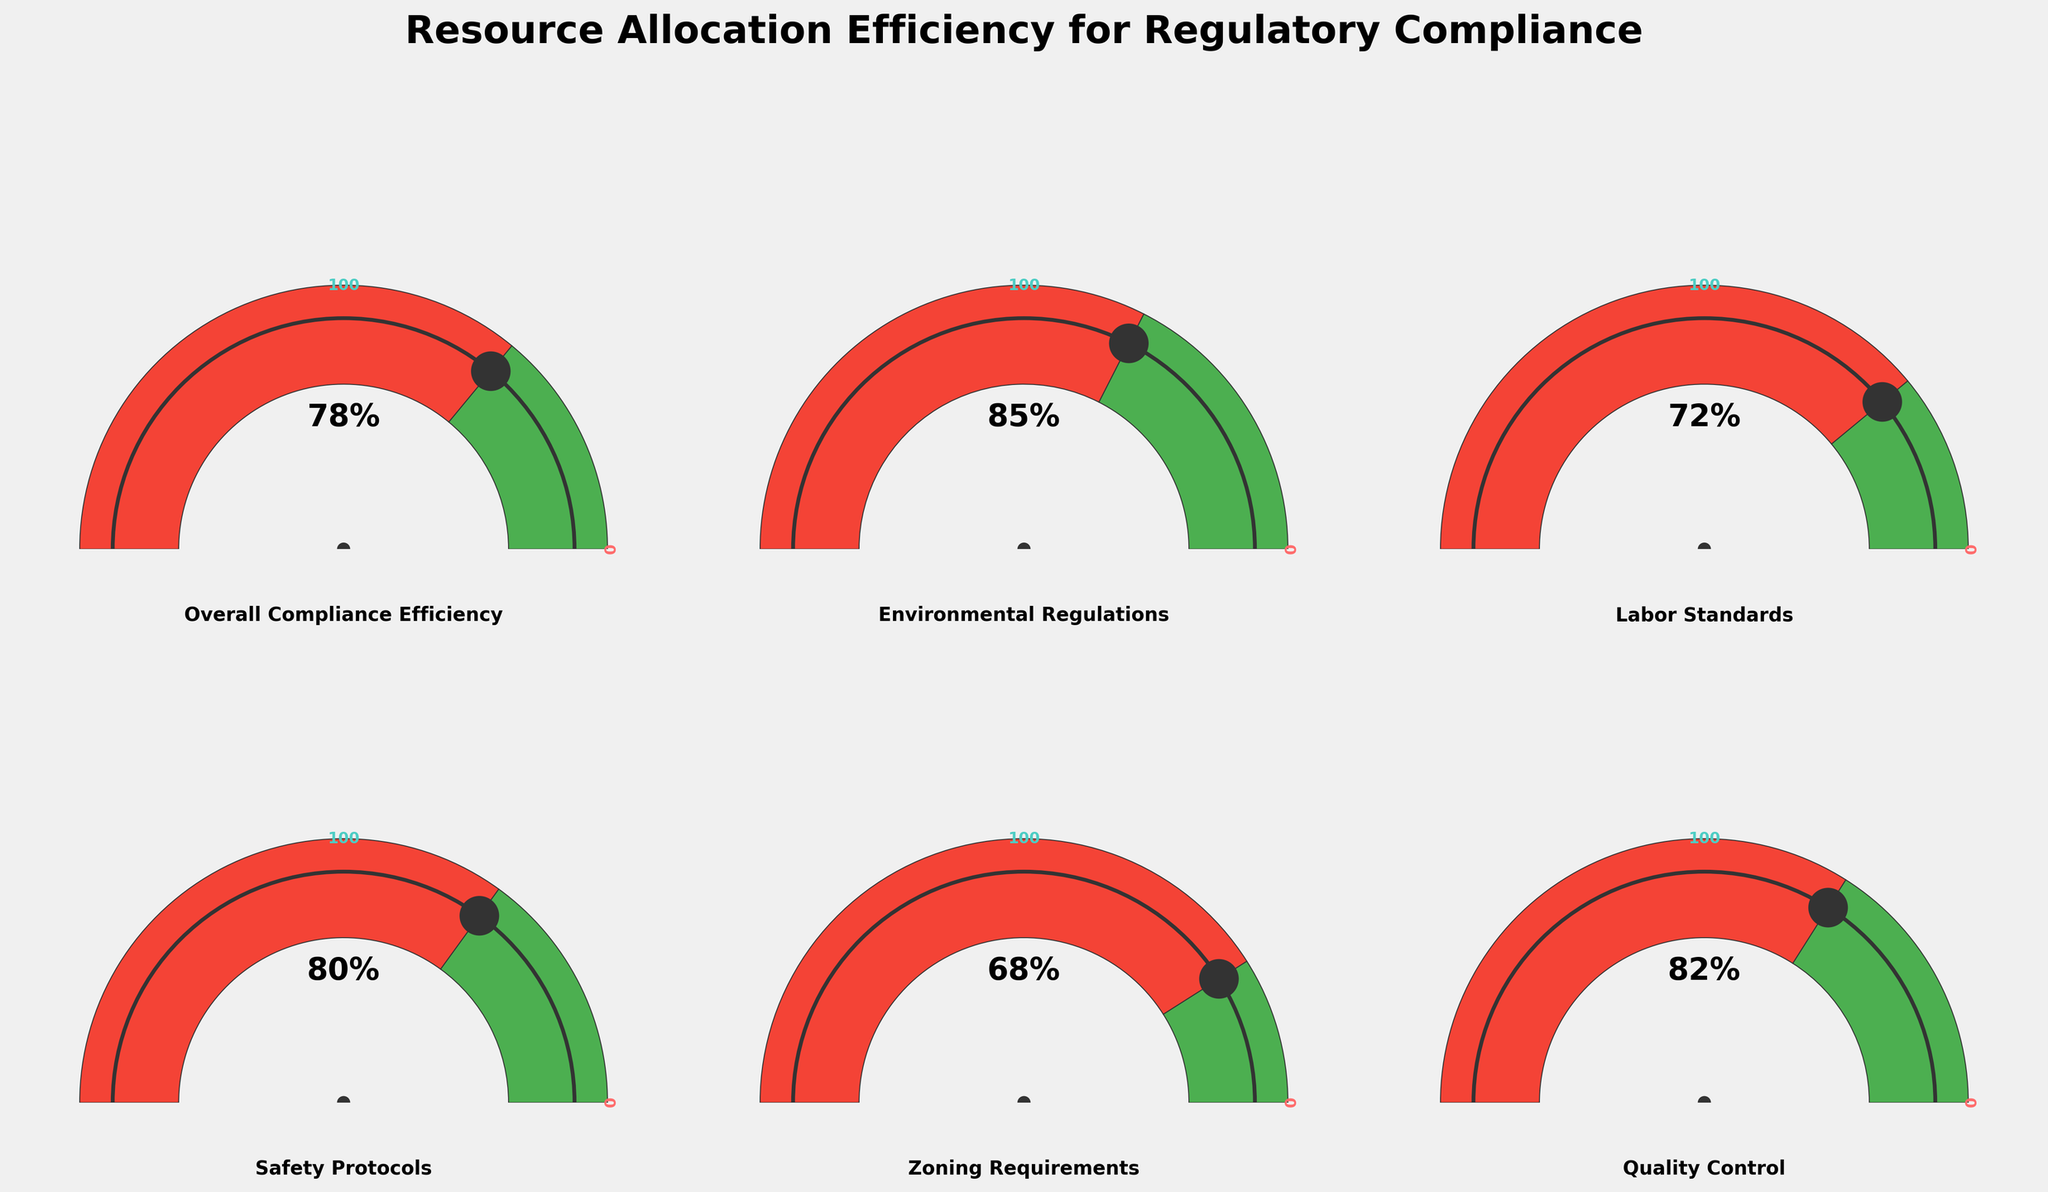What is the overall compliance efficiency? Look at the gauge chart labeled "Overall Compliance Efficiency" and read the percentage value indicated by the needle.
Answer: 78% Which category has the highest efficiency value? Examine all the gauge charts and identify the one with the highest percentage value.
Answer: Environmental Regulations Which category has the lowest efficiency value? Examine all the gauge charts and identify the one with the lowest percentage value.
Answer: Zoning Requirements How many categories have an efficiency value greater than 80%? Inspect each gauge chart, count the categories with values greater than 80%. There are "Overall Compliance Efficiency" (78%), "Environmental Regulations" (85%), "Safety Protocols" (80%), and "Quality Control" (82%).
Answer: 3 What's the average efficiency value for Labor Standards and Safety Protocols? Add the efficiency values of "Labor Standards" (72) and "Safety Protocols" (80) and divide by 2: (72 + 80) / 2.
Answer: 76 By how many percentage points is the efficiency value of Environmental Regulations higher than Zoning Requirements? Subtract the efficiency value of "Zoning Requirements" (68) from "Environmental Regulations" (85).
Answer: 17 What is the median efficiency value of all categories? Arrange the values in ascending order (68, 72, 78, 80, 82, 85) and find the middle value. For an even number of observations, average the two middle values: (78 + 80) / 2.
Answer: 79 Which categories have efficiency values below the overall compliance efficiency? Compare the efficiency values of all categories with the "Overall Compliance Efficiency" value of 78%. Identify the categories with lower values: "Labor Standards" (72) and "Zoning Requirements" (68).
Answer: Labor Standards, Zoning Requirements How many categories have an efficiency value between 70% and 80%? Count the categories where values fall within the range (inclusive): "Labor Standards" (72), "Safety Protocols" (80), and "Overall Compliance Efficiency" (78).
Answer: 3 What would be the average efficiency if Environmental Regulations improved to 90%? Replace the "Environmental Regulations" value (85) with 90 and calculate the new average: ((78 + 72 + 80 + 68 + 82 + 90) / 6).
Answer: 78.33 